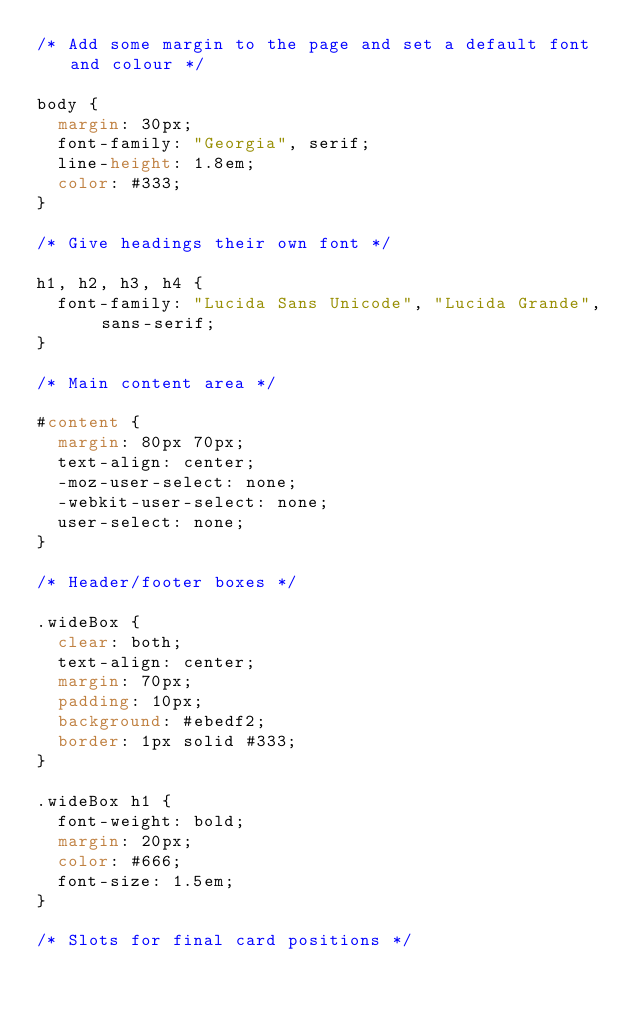Convert code to text. <code><loc_0><loc_0><loc_500><loc_500><_CSS_>/* Add some margin to the page and set a default font and colour */
 
body {
  margin: 30px;
  font-family: "Georgia", serif;
  line-height: 1.8em;
  color: #333;
}
 
/* Give headings their own font */
 
h1, h2, h3, h4 {
  font-family: "Lucida Sans Unicode", "Lucida Grande", sans-serif;
}
 
/* Main content area */
 
#content {
  margin: 80px 70px;
  text-align: center;
  -moz-user-select: none;
  -webkit-user-select: none;
  user-select: none;
}
 
/* Header/footer boxes */
 
.wideBox {
  clear: both;
  text-align: center;
  margin: 70px;
  padding: 10px;
  background: #ebedf2;
  border: 1px solid #333;
}
 
.wideBox h1 {
  font-weight: bold;
  margin: 20px;
  color: #666;
  font-size: 1.5em;
}
 
/* Slots for final card positions */
 </code> 